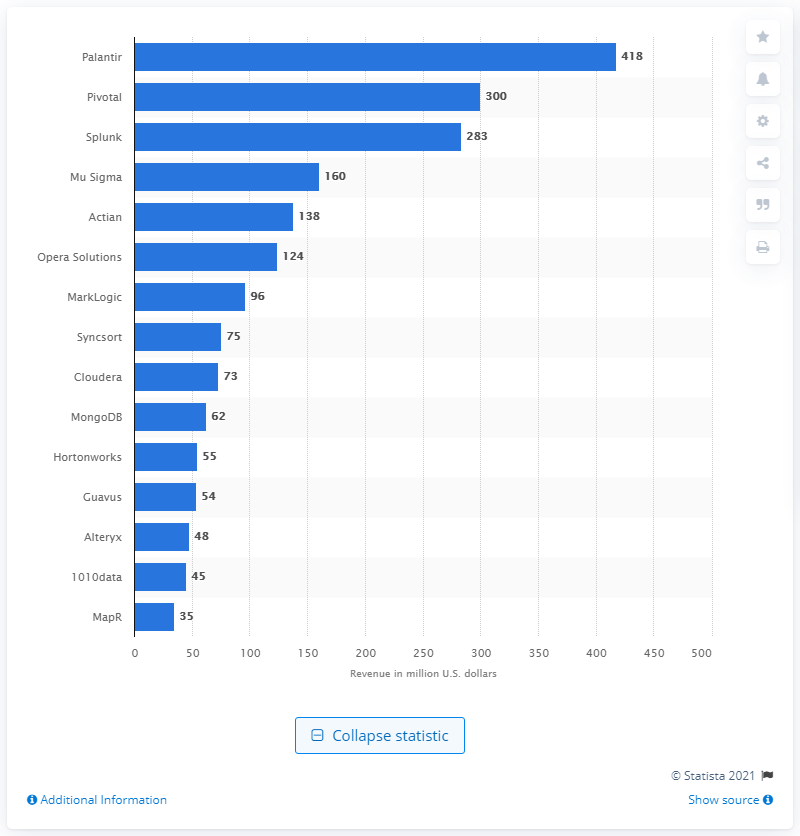Draw attention to some important aspects in this diagram. In 2013, Palantir, a data analysis specialist, achieved revenues of approximately 418 million U.S. dollars. Palantir generated approximately $418 million in revenue in 2013. 